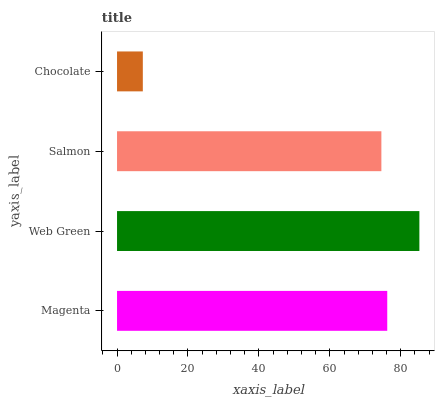Is Chocolate the minimum?
Answer yes or no. Yes. Is Web Green the maximum?
Answer yes or no. Yes. Is Salmon the minimum?
Answer yes or no. No. Is Salmon the maximum?
Answer yes or no. No. Is Web Green greater than Salmon?
Answer yes or no. Yes. Is Salmon less than Web Green?
Answer yes or no. Yes. Is Salmon greater than Web Green?
Answer yes or no. No. Is Web Green less than Salmon?
Answer yes or no. No. Is Magenta the high median?
Answer yes or no. Yes. Is Salmon the low median?
Answer yes or no. Yes. Is Web Green the high median?
Answer yes or no. No. Is Magenta the low median?
Answer yes or no. No. 